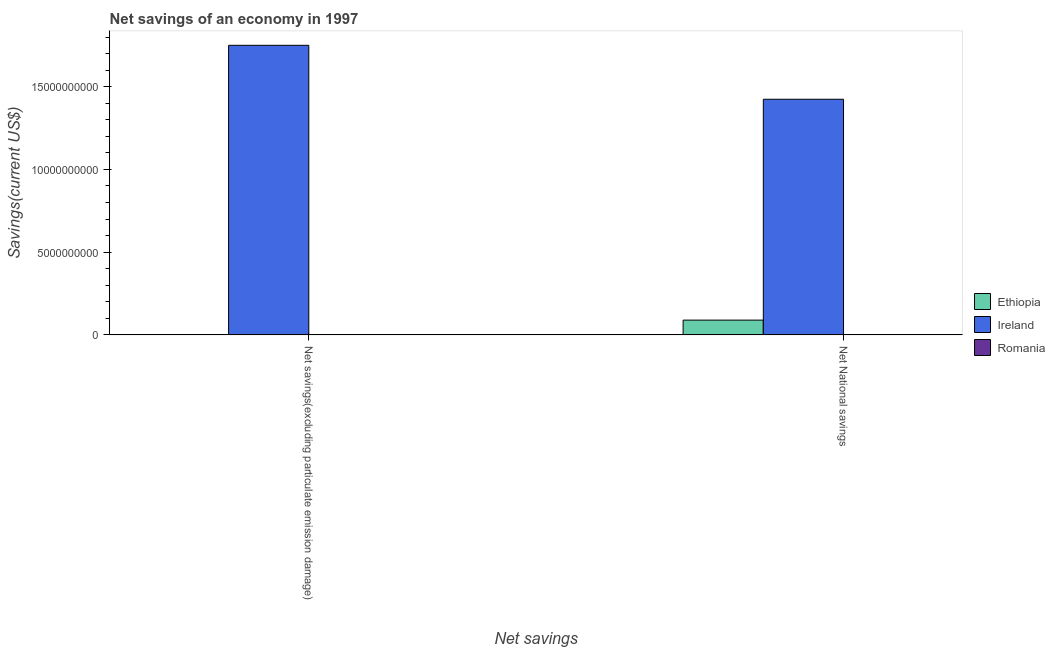How many different coloured bars are there?
Offer a very short reply. 2. Are the number of bars per tick equal to the number of legend labels?
Give a very brief answer. No. Are the number of bars on each tick of the X-axis equal?
Offer a very short reply. No. How many bars are there on the 2nd tick from the right?
Your answer should be compact. 1. What is the label of the 2nd group of bars from the left?
Offer a very short reply. Net National savings. What is the net national savings in Romania?
Ensure brevity in your answer.  0. Across all countries, what is the maximum net savings(excluding particulate emission damage)?
Offer a terse response. 1.75e+1. In which country was the net national savings maximum?
Your answer should be compact. Ireland. What is the total net savings(excluding particulate emission damage) in the graph?
Keep it short and to the point. 1.75e+1. What is the difference between the net national savings in Ireland and that in Ethiopia?
Your answer should be very brief. 1.33e+1. What is the difference between the net savings(excluding particulate emission damage) in Ireland and the net national savings in Romania?
Provide a short and direct response. 1.75e+1. What is the average net national savings per country?
Ensure brevity in your answer.  5.04e+09. What is the difference between the net national savings and net savings(excluding particulate emission damage) in Ireland?
Offer a terse response. -3.26e+09. In how many countries, is the net national savings greater than 13000000000 US$?
Your response must be concise. 1. What is the ratio of the net national savings in Ireland to that in Ethiopia?
Your answer should be compact. 15.95. Is the net national savings in Ethiopia less than that in Ireland?
Your response must be concise. Yes. In how many countries, is the net national savings greater than the average net national savings taken over all countries?
Ensure brevity in your answer.  1. How many bars are there?
Keep it short and to the point. 3. Are all the bars in the graph horizontal?
Offer a very short reply. No. Are the values on the major ticks of Y-axis written in scientific E-notation?
Keep it short and to the point. No. Does the graph contain any zero values?
Keep it short and to the point. Yes. Does the graph contain grids?
Provide a short and direct response. No. How are the legend labels stacked?
Make the answer very short. Vertical. What is the title of the graph?
Your answer should be very brief. Net savings of an economy in 1997. What is the label or title of the X-axis?
Keep it short and to the point. Net savings. What is the label or title of the Y-axis?
Give a very brief answer. Savings(current US$). What is the Savings(current US$) in Ireland in Net savings(excluding particulate emission damage)?
Your answer should be very brief. 1.75e+1. What is the Savings(current US$) of Romania in Net savings(excluding particulate emission damage)?
Your answer should be compact. 0. What is the Savings(current US$) of Ethiopia in Net National savings?
Provide a succinct answer. 8.93e+08. What is the Savings(current US$) in Ireland in Net National savings?
Make the answer very short. 1.42e+1. What is the Savings(current US$) in Romania in Net National savings?
Keep it short and to the point. 0. Across all Net savings, what is the maximum Savings(current US$) of Ethiopia?
Keep it short and to the point. 8.93e+08. Across all Net savings, what is the maximum Savings(current US$) in Ireland?
Provide a short and direct response. 1.75e+1. Across all Net savings, what is the minimum Savings(current US$) in Ethiopia?
Offer a terse response. 0. Across all Net savings, what is the minimum Savings(current US$) of Ireland?
Your answer should be compact. 1.42e+1. What is the total Savings(current US$) of Ethiopia in the graph?
Keep it short and to the point. 8.93e+08. What is the total Savings(current US$) of Ireland in the graph?
Give a very brief answer. 3.17e+1. What is the total Savings(current US$) in Romania in the graph?
Your response must be concise. 0. What is the difference between the Savings(current US$) in Ireland in Net savings(excluding particulate emission damage) and that in Net National savings?
Your answer should be very brief. 3.26e+09. What is the average Savings(current US$) in Ethiopia per Net savings?
Your answer should be very brief. 4.46e+08. What is the average Savings(current US$) in Ireland per Net savings?
Make the answer very short. 1.59e+1. What is the difference between the Savings(current US$) in Ethiopia and Savings(current US$) in Ireland in Net National savings?
Keep it short and to the point. -1.33e+1. What is the ratio of the Savings(current US$) of Ireland in Net savings(excluding particulate emission damage) to that in Net National savings?
Ensure brevity in your answer.  1.23. What is the difference between the highest and the second highest Savings(current US$) in Ireland?
Offer a very short reply. 3.26e+09. What is the difference between the highest and the lowest Savings(current US$) in Ethiopia?
Give a very brief answer. 8.93e+08. What is the difference between the highest and the lowest Savings(current US$) in Ireland?
Offer a very short reply. 3.26e+09. 